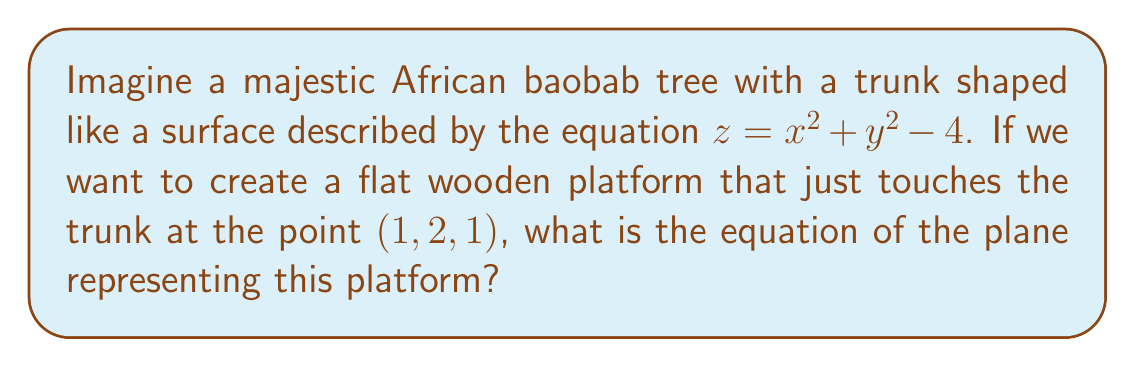Show me your answer to this math problem. Let's approach this step-by-step:

1) The surface of the baobab trunk is given by $f(x,y,z) = x^2 + y^2 - z - 4 = 0$

2) To find the equation of the tangent plane, we need to use the gradient of f at the point of tangency (1, 2, 1):

   $\nabla f = (f_x, f_y, f_z) = (2x, 2y, -1)$

3) At the point (1, 2, 1), the gradient is:

   $\nabla f(1,2,1) = (2(1), 2(2), -1) = (2, 4, -1)$

4) The equation of a plane tangent to a surface at a point $(x_0, y_0, z_0)$ is:

   $f_x(x_0, y_0, z_0)(x - x_0) + f_y(x_0, y_0, z_0)(y - y_0) + f_z(x_0, y_0, z_0)(z - z_0) = 0$

5) Substituting our values:

   $2(x - 1) + 4(y - 2) + (-1)(z - 1) = 0$

6) Simplifying:

   $2x - 2 + 4y - 8 - z + 1 = 0$
   $2x + 4y - z - 9 = 0$

7) Rearranging to standard form:

   $2x + 4y - z = 9$

This is the equation of the plane representing our wooden platform that just touches the baobab trunk.
Answer: $2x + 4y - z = 9$ 